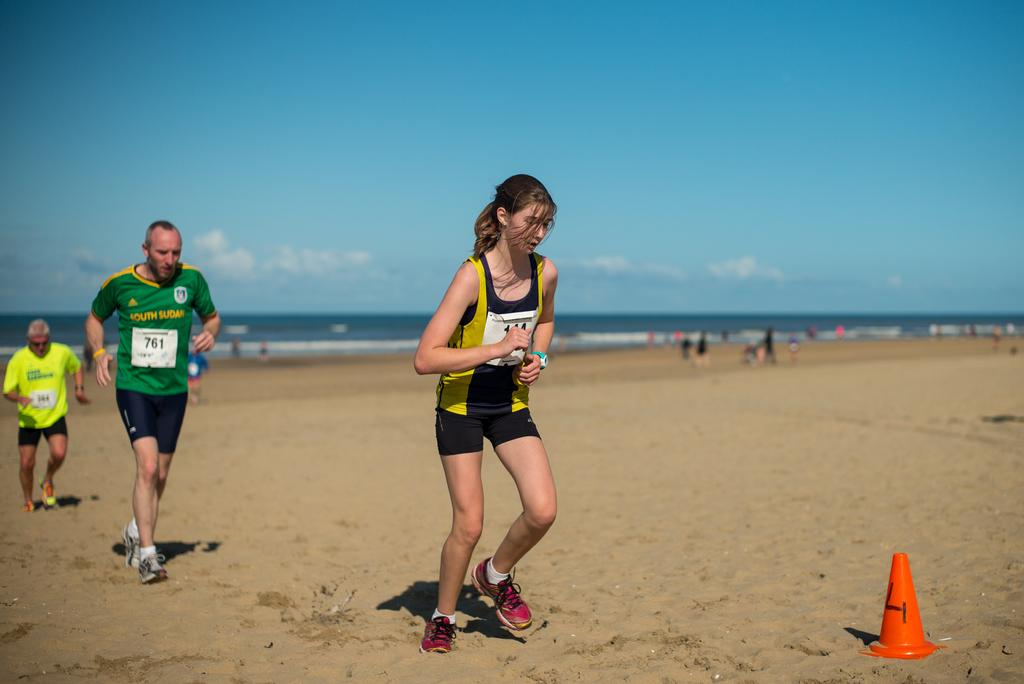How many people are in the group in the image? There is a group of people in the image, but the exact number is not specified. What are some people in the group doing? Some people in the group are running. What can be seen in the background of the image? There are clouds and a sea visible in the background of the image. Where is the cone located in the image? The cone is in the bottom right-hand corner of the image. What type of apple is being used to wipe the cloth in the image? There is no apple or cloth present in the image. What time of day is depicted in the image? The time of day is not specified in the image. 